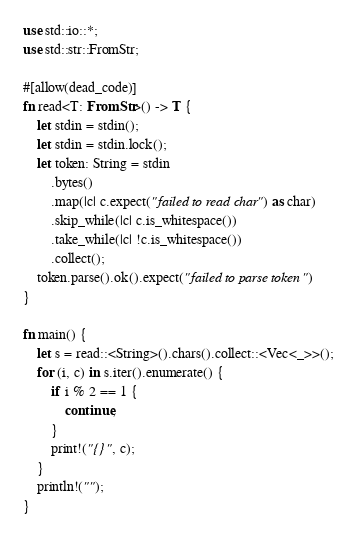Convert code to text. <code><loc_0><loc_0><loc_500><loc_500><_Rust_>use std::io::*;
use std::str::FromStr;

#[allow(dead_code)]
fn read<T: FromStr>() -> T {
    let stdin = stdin();
    let stdin = stdin.lock();
    let token: String = stdin
        .bytes()
        .map(|c| c.expect("failed to read char") as char)
        .skip_while(|c| c.is_whitespace())
        .take_while(|c| !c.is_whitespace())
        .collect();
    token.parse().ok().expect("failed to parse token")
}

fn main() {
    let s = read::<String>().chars().collect::<Vec<_>>();
    for (i, c) in s.iter().enumerate() {
        if i % 2 == 1 {
            continue;
        }
        print!("{}", c);
    }
    println!("");
}
</code> 